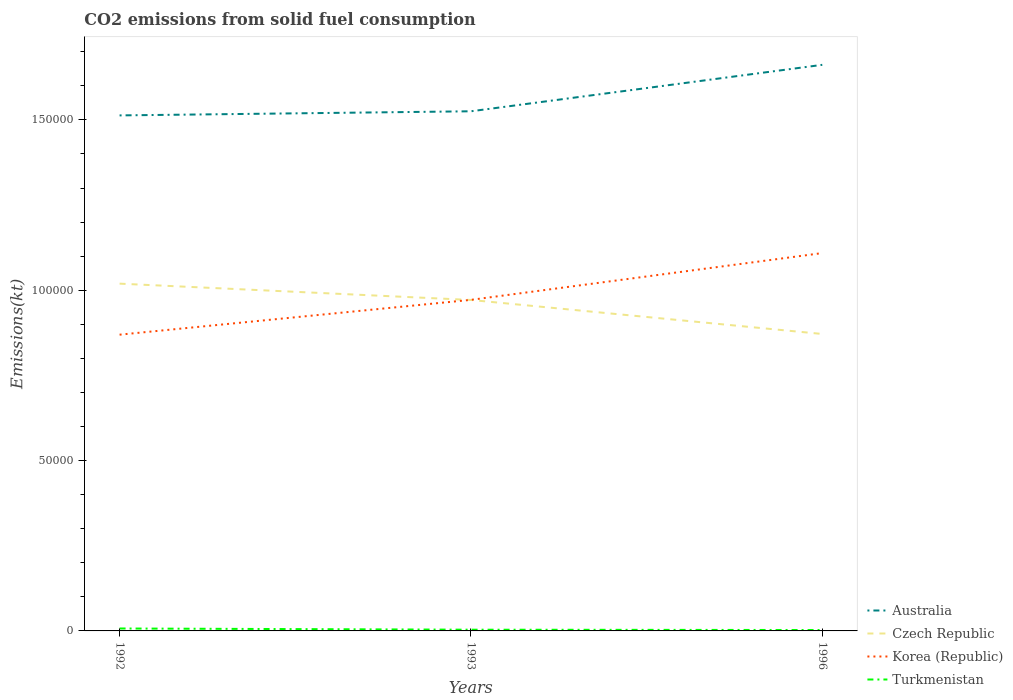Does the line corresponding to Turkmenistan intersect with the line corresponding to Australia?
Keep it short and to the point. No. Is the number of lines equal to the number of legend labels?
Keep it short and to the point. Yes. Across all years, what is the maximum amount of CO2 emitted in Czech Republic?
Provide a short and direct response. 8.72e+04. In which year was the amount of CO2 emitted in Czech Republic maximum?
Make the answer very short. 1996. What is the total amount of CO2 emitted in Czech Republic in the graph?
Your answer should be compact. 1.48e+04. What is the difference between the highest and the second highest amount of CO2 emitted in Australia?
Offer a very short reply. 1.48e+04. What is the difference between the highest and the lowest amount of CO2 emitted in Czech Republic?
Make the answer very short. 2. Is the amount of CO2 emitted in Australia strictly greater than the amount of CO2 emitted in Turkmenistan over the years?
Offer a very short reply. No. Does the graph contain grids?
Your response must be concise. No. Where does the legend appear in the graph?
Keep it short and to the point. Bottom right. How are the legend labels stacked?
Ensure brevity in your answer.  Vertical. What is the title of the graph?
Your response must be concise. CO2 emissions from solid fuel consumption. What is the label or title of the Y-axis?
Make the answer very short. Emissions(kt). What is the Emissions(kt) of Australia in 1992?
Make the answer very short. 1.51e+05. What is the Emissions(kt) in Czech Republic in 1992?
Provide a short and direct response. 1.02e+05. What is the Emissions(kt) of Korea (Republic) in 1992?
Make the answer very short. 8.70e+04. What is the Emissions(kt) in Turkmenistan in 1992?
Give a very brief answer. 715.07. What is the Emissions(kt) in Australia in 1993?
Make the answer very short. 1.53e+05. What is the Emissions(kt) of Czech Republic in 1993?
Offer a very short reply. 9.71e+04. What is the Emissions(kt) in Korea (Republic) in 1993?
Provide a short and direct response. 9.72e+04. What is the Emissions(kt) of Turkmenistan in 1993?
Your response must be concise. 359.37. What is the Emissions(kt) of Australia in 1996?
Offer a terse response. 1.66e+05. What is the Emissions(kt) of Czech Republic in 1996?
Your answer should be compact. 8.72e+04. What is the Emissions(kt) in Korea (Republic) in 1996?
Keep it short and to the point. 1.11e+05. What is the Emissions(kt) in Turkmenistan in 1996?
Give a very brief answer. 264.02. Across all years, what is the maximum Emissions(kt) of Australia?
Ensure brevity in your answer.  1.66e+05. Across all years, what is the maximum Emissions(kt) in Czech Republic?
Give a very brief answer. 1.02e+05. Across all years, what is the maximum Emissions(kt) in Korea (Republic)?
Your answer should be compact. 1.11e+05. Across all years, what is the maximum Emissions(kt) in Turkmenistan?
Provide a succinct answer. 715.07. Across all years, what is the minimum Emissions(kt) in Australia?
Make the answer very short. 1.51e+05. Across all years, what is the minimum Emissions(kt) in Czech Republic?
Provide a succinct answer. 8.72e+04. Across all years, what is the minimum Emissions(kt) in Korea (Republic)?
Your response must be concise. 8.70e+04. Across all years, what is the minimum Emissions(kt) of Turkmenistan?
Ensure brevity in your answer.  264.02. What is the total Emissions(kt) in Australia in the graph?
Provide a short and direct response. 4.70e+05. What is the total Emissions(kt) in Czech Republic in the graph?
Offer a terse response. 2.86e+05. What is the total Emissions(kt) in Korea (Republic) in the graph?
Keep it short and to the point. 2.95e+05. What is the total Emissions(kt) of Turkmenistan in the graph?
Your answer should be very brief. 1338.45. What is the difference between the Emissions(kt) in Australia in 1992 and that in 1993?
Offer a very short reply. -1210.11. What is the difference between the Emissions(kt) in Czech Republic in 1992 and that in 1993?
Provide a short and direct response. 4789.1. What is the difference between the Emissions(kt) in Korea (Republic) in 1992 and that in 1993?
Offer a very short reply. -1.02e+04. What is the difference between the Emissions(kt) in Turkmenistan in 1992 and that in 1993?
Your answer should be compact. 355.7. What is the difference between the Emissions(kt) in Australia in 1992 and that in 1996?
Your answer should be very brief. -1.48e+04. What is the difference between the Emissions(kt) of Czech Republic in 1992 and that in 1996?
Give a very brief answer. 1.48e+04. What is the difference between the Emissions(kt) of Korea (Republic) in 1992 and that in 1996?
Offer a very short reply. -2.40e+04. What is the difference between the Emissions(kt) of Turkmenistan in 1992 and that in 1996?
Make the answer very short. 451.04. What is the difference between the Emissions(kt) in Australia in 1993 and that in 1996?
Provide a succinct answer. -1.36e+04. What is the difference between the Emissions(kt) in Czech Republic in 1993 and that in 1996?
Your answer should be compact. 9985.24. What is the difference between the Emissions(kt) in Korea (Republic) in 1993 and that in 1996?
Ensure brevity in your answer.  -1.37e+04. What is the difference between the Emissions(kt) in Turkmenistan in 1993 and that in 1996?
Your response must be concise. 95.34. What is the difference between the Emissions(kt) in Australia in 1992 and the Emissions(kt) in Czech Republic in 1993?
Provide a succinct answer. 5.42e+04. What is the difference between the Emissions(kt) in Australia in 1992 and the Emissions(kt) in Korea (Republic) in 1993?
Offer a very short reply. 5.41e+04. What is the difference between the Emissions(kt) of Australia in 1992 and the Emissions(kt) of Turkmenistan in 1993?
Give a very brief answer. 1.51e+05. What is the difference between the Emissions(kt) in Czech Republic in 1992 and the Emissions(kt) in Korea (Republic) in 1993?
Your response must be concise. 4756.1. What is the difference between the Emissions(kt) of Czech Republic in 1992 and the Emissions(kt) of Turkmenistan in 1993?
Offer a terse response. 1.02e+05. What is the difference between the Emissions(kt) of Korea (Republic) in 1992 and the Emissions(kt) of Turkmenistan in 1993?
Give a very brief answer. 8.66e+04. What is the difference between the Emissions(kt) of Australia in 1992 and the Emissions(kt) of Czech Republic in 1996?
Ensure brevity in your answer.  6.42e+04. What is the difference between the Emissions(kt) of Australia in 1992 and the Emissions(kt) of Korea (Republic) in 1996?
Your answer should be very brief. 4.04e+04. What is the difference between the Emissions(kt) of Australia in 1992 and the Emissions(kt) of Turkmenistan in 1996?
Provide a succinct answer. 1.51e+05. What is the difference between the Emissions(kt) of Czech Republic in 1992 and the Emissions(kt) of Korea (Republic) in 1996?
Offer a very short reply. -8973.15. What is the difference between the Emissions(kt) of Czech Republic in 1992 and the Emissions(kt) of Turkmenistan in 1996?
Make the answer very short. 1.02e+05. What is the difference between the Emissions(kt) of Korea (Republic) in 1992 and the Emissions(kt) of Turkmenistan in 1996?
Provide a succinct answer. 8.67e+04. What is the difference between the Emissions(kt) in Australia in 1993 and the Emissions(kt) in Czech Republic in 1996?
Your response must be concise. 6.54e+04. What is the difference between the Emissions(kt) of Australia in 1993 and the Emissions(kt) of Korea (Republic) in 1996?
Your response must be concise. 4.16e+04. What is the difference between the Emissions(kt) in Australia in 1993 and the Emissions(kt) in Turkmenistan in 1996?
Your response must be concise. 1.52e+05. What is the difference between the Emissions(kt) in Czech Republic in 1993 and the Emissions(kt) in Korea (Republic) in 1996?
Offer a very short reply. -1.38e+04. What is the difference between the Emissions(kt) in Czech Republic in 1993 and the Emissions(kt) in Turkmenistan in 1996?
Provide a short and direct response. 9.69e+04. What is the difference between the Emissions(kt) in Korea (Republic) in 1993 and the Emissions(kt) in Turkmenistan in 1996?
Ensure brevity in your answer.  9.69e+04. What is the average Emissions(kt) of Australia per year?
Offer a terse response. 1.57e+05. What is the average Emissions(kt) in Czech Republic per year?
Give a very brief answer. 9.54e+04. What is the average Emissions(kt) in Korea (Republic) per year?
Offer a terse response. 9.84e+04. What is the average Emissions(kt) of Turkmenistan per year?
Your response must be concise. 446.15. In the year 1992, what is the difference between the Emissions(kt) in Australia and Emissions(kt) in Czech Republic?
Your response must be concise. 4.94e+04. In the year 1992, what is the difference between the Emissions(kt) in Australia and Emissions(kt) in Korea (Republic)?
Offer a terse response. 6.44e+04. In the year 1992, what is the difference between the Emissions(kt) of Australia and Emissions(kt) of Turkmenistan?
Make the answer very short. 1.51e+05. In the year 1992, what is the difference between the Emissions(kt) in Czech Republic and Emissions(kt) in Korea (Republic)?
Give a very brief answer. 1.50e+04. In the year 1992, what is the difference between the Emissions(kt) in Czech Republic and Emissions(kt) in Turkmenistan?
Ensure brevity in your answer.  1.01e+05. In the year 1992, what is the difference between the Emissions(kt) of Korea (Republic) and Emissions(kt) of Turkmenistan?
Offer a very short reply. 8.62e+04. In the year 1993, what is the difference between the Emissions(kt) of Australia and Emissions(kt) of Czech Republic?
Your response must be concise. 5.54e+04. In the year 1993, what is the difference between the Emissions(kt) in Australia and Emissions(kt) in Korea (Republic)?
Give a very brief answer. 5.54e+04. In the year 1993, what is the difference between the Emissions(kt) of Australia and Emissions(kt) of Turkmenistan?
Provide a succinct answer. 1.52e+05. In the year 1993, what is the difference between the Emissions(kt) in Czech Republic and Emissions(kt) in Korea (Republic)?
Keep it short and to the point. -33. In the year 1993, what is the difference between the Emissions(kt) in Czech Republic and Emissions(kt) in Turkmenistan?
Offer a terse response. 9.68e+04. In the year 1993, what is the difference between the Emissions(kt) in Korea (Republic) and Emissions(kt) in Turkmenistan?
Offer a terse response. 9.68e+04. In the year 1996, what is the difference between the Emissions(kt) of Australia and Emissions(kt) of Czech Republic?
Your response must be concise. 7.90e+04. In the year 1996, what is the difference between the Emissions(kt) in Australia and Emissions(kt) in Korea (Republic)?
Keep it short and to the point. 5.53e+04. In the year 1996, what is the difference between the Emissions(kt) in Australia and Emissions(kt) in Turkmenistan?
Provide a short and direct response. 1.66e+05. In the year 1996, what is the difference between the Emissions(kt) of Czech Republic and Emissions(kt) of Korea (Republic)?
Your answer should be very brief. -2.37e+04. In the year 1996, what is the difference between the Emissions(kt) of Czech Republic and Emissions(kt) of Turkmenistan?
Provide a succinct answer. 8.69e+04. In the year 1996, what is the difference between the Emissions(kt) in Korea (Republic) and Emissions(kt) in Turkmenistan?
Offer a terse response. 1.11e+05. What is the ratio of the Emissions(kt) in Czech Republic in 1992 to that in 1993?
Provide a succinct answer. 1.05. What is the ratio of the Emissions(kt) of Korea (Republic) in 1992 to that in 1993?
Provide a succinct answer. 0.89. What is the ratio of the Emissions(kt) of Turkmenistan in 1992 to that in 1993?
Ensure brevity in your answer.  1.99. What is the ratio of the Emissions(kt) in Australia in 1992 to that in 1996?
Your answer should be compact. 0.91. What is the ratio of the Emissions(kt) in Czech Republic in 1992 to that in 1996?
Offer a very short reply. 1.17. What is the ratio of the Emissions(kt) of Korea (Republic) in 1992 to that in 1996?
Your answer should be compact. 0.78. What is the ratio of the Emissions(kt) of Turkmenistan in 1992 to that in 1996?
Ensure brevity in your answer.  2.71. What is the ratio of the Emissions(kt) in Australia in 1993 to that in 1996?
Your answer should be very brief. 0.92. What is the ratio of the Emissions(kt) of Czech Republic in 1993 to that in 1996?
Ensure brevity in your answer.  1.11. What is the ratio of the Emissions(kt) in Korea (Republic) in 1993 to that in 1996?
Make the answer very short. 0.88. What is the ratio of the Emissions(kt) in Turkmenistan in 1993 to that in 1996?
Keep it short and to the point. 1.36. What is the difference between the highest and the second highest Emissions(kt) of Australia?
Your response must be concise. 1.36e+04. What is the difference between the highest and the second highest Emissions(kt) of Czech Republic?
Provide a succinct answer. 4789.1. What is the difference between the highest and the second highest Emissions(kt) of Korea (Republic)?
Make the answer very short. 1.37e+04. What is the difference between the highest and the second highest Emissions(kt) in Turkmenistan?
Offer a very short reply. 355.7. What is the difference between the highest and the lowest Emissions(kt) of Australia?
Give a very brief answer. 1.48e+04. What is the difference between the highest and the lowest Emissions(kt) of Czech Republic?
Offer a terse response. 1.48e+04. What is the difference between the highest and the lowest Emissions(kt) in Korea (Republic)?
Ensure brevity in your answer.  2.40e+04. What is the difference between the highest and the lowest Emissions(kt) of Turkmenistan?
Make the answer very short. 451.04. 